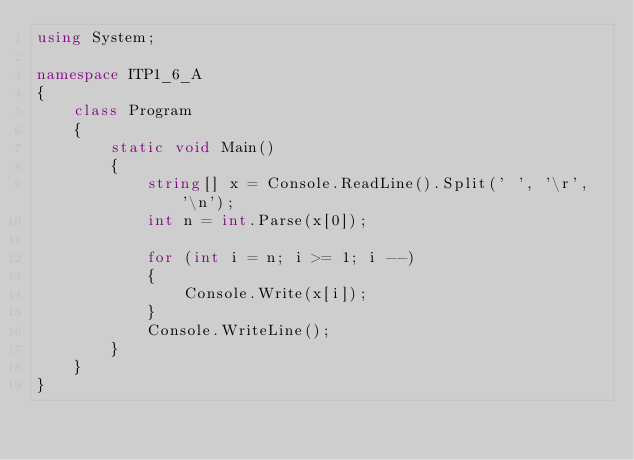Convert code to text. <code><loc_0><loc_0><loc_500><loc_500><_C#_>using System;

namespace ITP1_6_A
{
    class Program
    {
        static void Main()
        {
            string[] x = Console.ReadLine().Split(' ', '\r', '\n');
            int n = int.Parse(x[0]);
            
            for (int i = n; i >= 1; i --)
            {
                Console.Write(x[i]);
            }
            Console.WriteLine();
        }
    }
}
</code> 